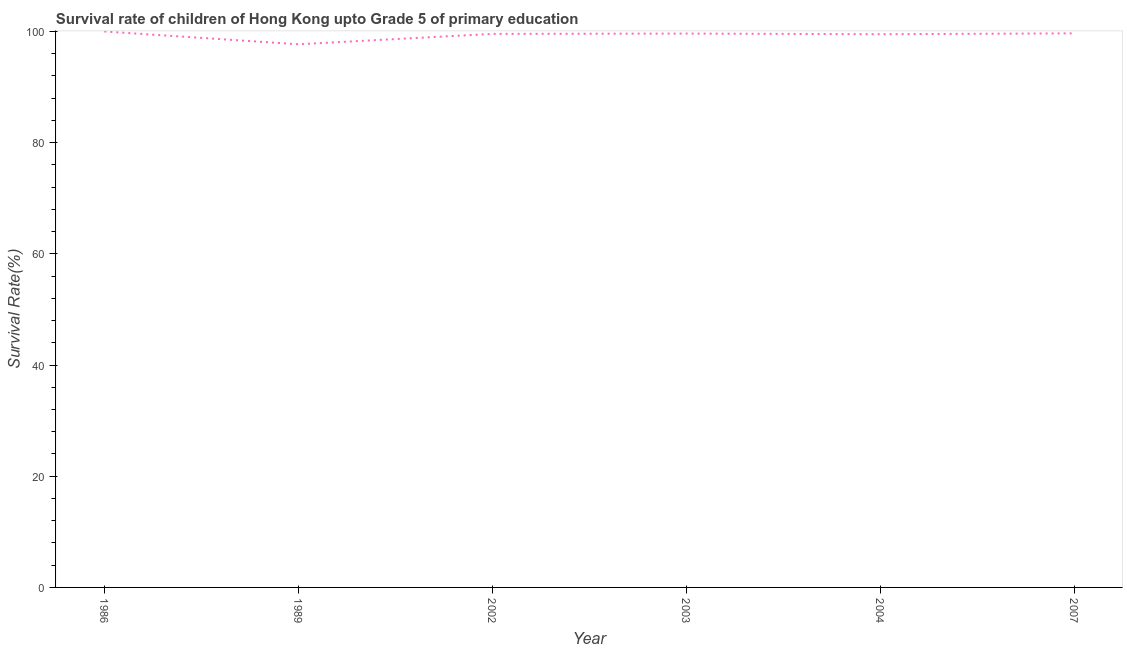What is the survival rate in 2002?
Give a very brief answer. 99.56. Across all years, what is the minimum survival rate?
Give a very brief answer. 97.7. In which year was the survival rate maximum?
Keep it short and to the point. 1986. What is the sum of the survival rate?
Your response must be concise. 596.05. What is the difference between the survival rate in 2002 and 2003?
Ensure brevity in your answer.  -0.06. What is the average survival rate per year?
Your answer should be very brief. 99.34. What is the median survival rate?
Make the answer very short. 99.59. Do a majority of the years between 2004 and 1989 (inclusive) have survival rate greater than 68 %?
Ensure brevity in your answer.  Yes. What is the ratio of the survival rate in 1989 to that in 2004?
Your response must be concise. 0.98. Is the difference between the survival rate in 2002 and 2007 greater than the difference between any two years?
Your response must be concise. No. What is the difference between the highest and the second highest survival rate?
Your answer should be very brief. 0.34. What is the difference between the highest and the lowest survival rate?
Provide a short and direct response. 2.3. How many years are there in the graph?
Your response must be concise. 6. Are the values on the major ticks of Y-axis written in scientific E-notation?
Make the answer very short. No. Does the graph contain grids?
Your answer should be compact. No. What is the title of the graph?
Your response must be concise. Survival rate of children of Hong Kong upto Grade 5 of primary education. What is the label or title of the Y-axis?
Offer a very short reply. Survival Rate(%). What is the Survival Rate(%) in 1986?
Offer a very short reply. 100. What is the Survival Rate(%) of 1989?
Keep it short and to the point. 97.7. What is the Survival Rate(%) in 2002?
Make the answer very short. 99.56. What is the Survival Rate(%) in 2003?
Ensure brevity in your answer.  99.62. What is the Survival Rate(%) of 2004?
Offer a very short reply. 99.5. What is the Survival Rate(%) of 2007?
Keep it short and to the point. 99.66. What is the difference between the Survival Rate(%) in 1986 and 1989?
Make the answer very short. 2.3. What is the difference between the Survival Rate(%) in 1986 and 2002?
Your answer should be very brief. 0.44. What is the difference between the Survival Rate(%) in 1986 and 2003?
Make the answer very short. 0.38. What is the difference between the Survival Rate(%) in 1986 and 2004?
Your answer should be very brief. 0.5. What is the difference between the Survival Rate(%) in 1986 and 2007?
Your answer should be very brief. 0.34. What is the difference between the Survival Rate(%) in 1989 and 2002?
Offer a very short reply. -1.87. What is the difference between the Survival Rate(%) in 1989 and 2003?
Your answer should be very brief. -1.93. What is the difference between the Survival Rate(%) in 1989 and 2004?
Provide a succinct answer. -1.81. What is the difference between the Survival Rate(%) in 1989 and 2007?
Your response must be concise. -1.96. What is the difference between the Survival Rate(%) in 2002 and 2003?
Make the answer very short. -0.06. What is the difference between the Survival Rate(%) in 2002 and 2007?
Give a very brief answer. -0.1. What is the difference between the Survival Rate(%) in 2003 and 2004?
Offer a very short reply. 0.12. What is the difference between the Survival Rate(%) in 2003 and 2007?
Your answer should be compact. -0.04. What is the difference between the Survival Rate(%) in 2004 and 2007?
Your response must be concise. -0.16. What is the ratio of the Survival Rate(%) in 1986 to that in 2002?
Your answer should be very brief. 1. What is the ratio of the Survival Rate(%) in 1986 to that in 2004?
Give a very brief answer. 1. What is the ratio of the Survival Rate(%) in 1989 to that in 2003?
Your answer should be very brief. 0.98. What is the ratio of the Survival Rate(%) in 1989 to that in 2004?
Provide a short and direct response. 0.98. What is the ratio of the Survival Rate(%) in 1989 to that in 2007?
Offer a very short reply. 0.98. What is the ratio of the Survival Rate(%) in 2003 to that in 2004?
Your answer should be compact. 1. What is the ratio of the Survival Rate(%) in 2003 to that in 2007?
Your answer should be compact. 1. 